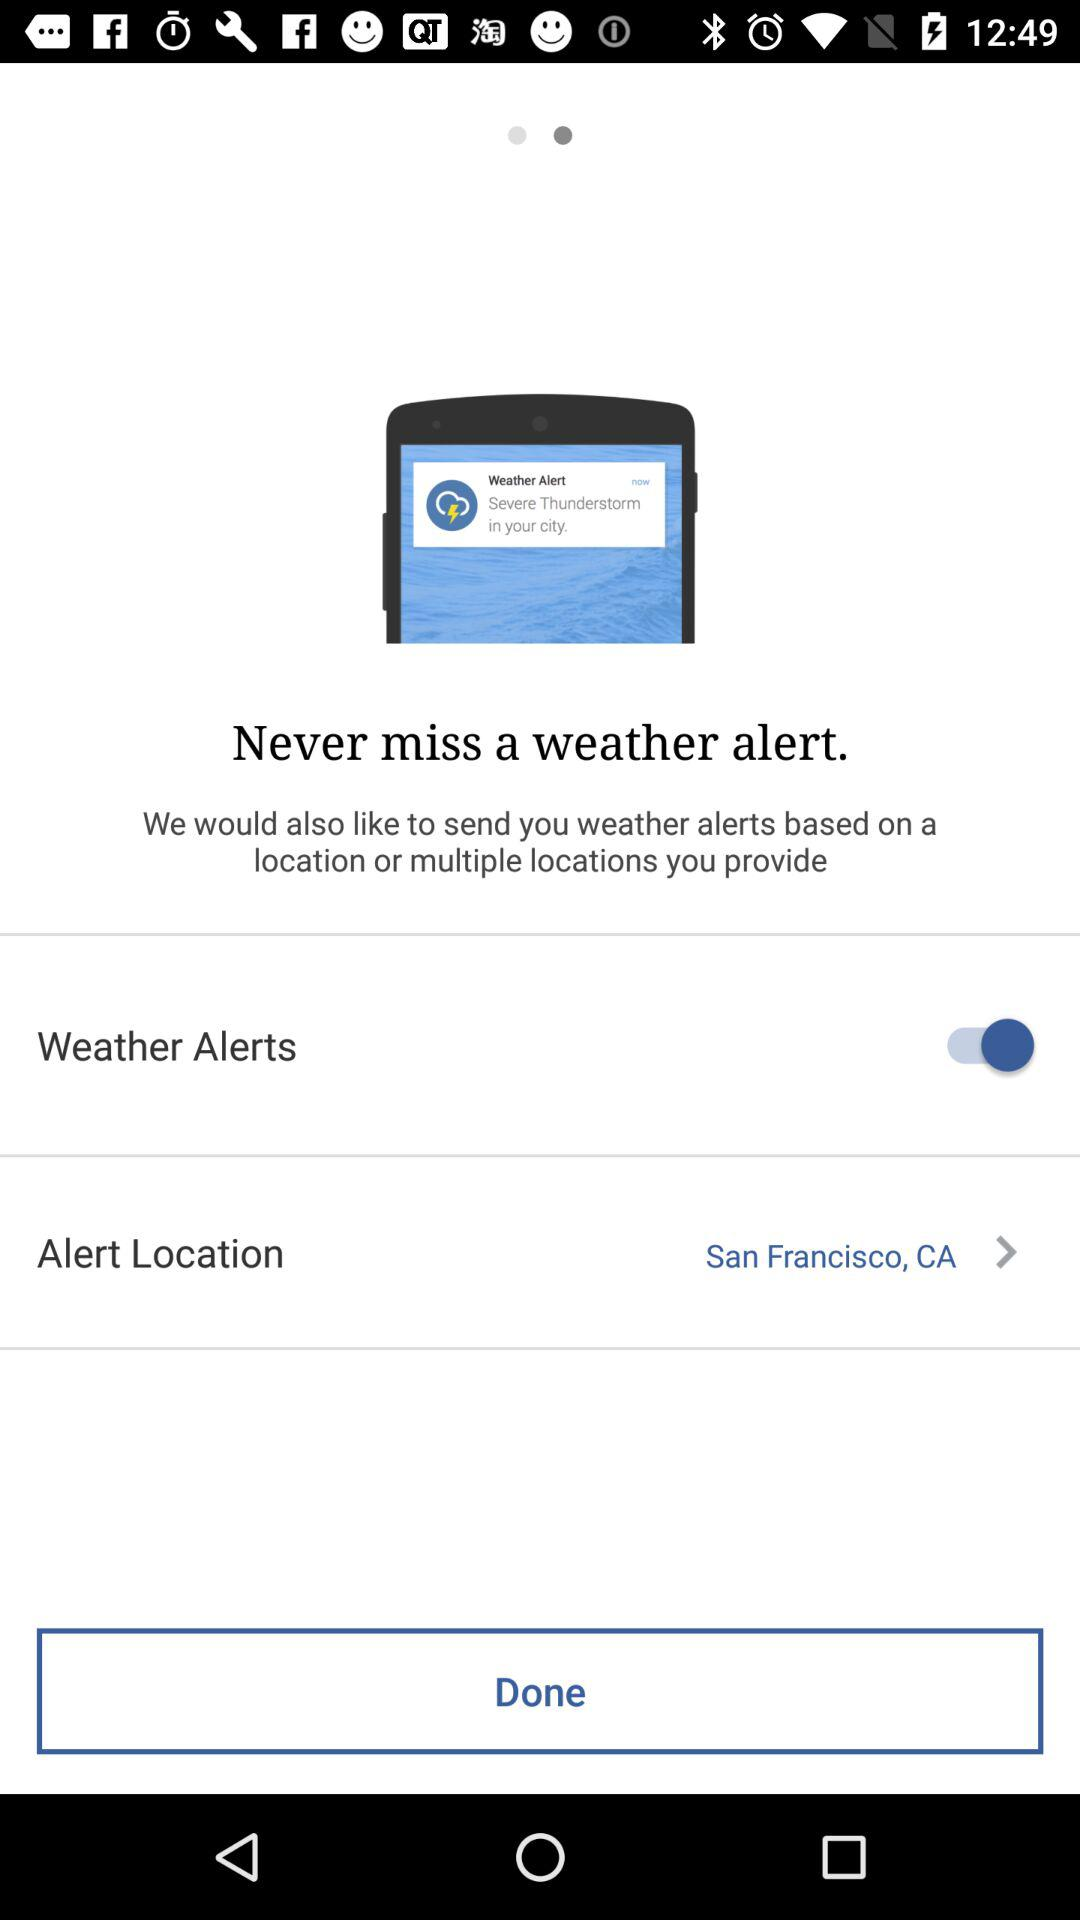What is the alert location? The alert location is San Francisco, CA. 